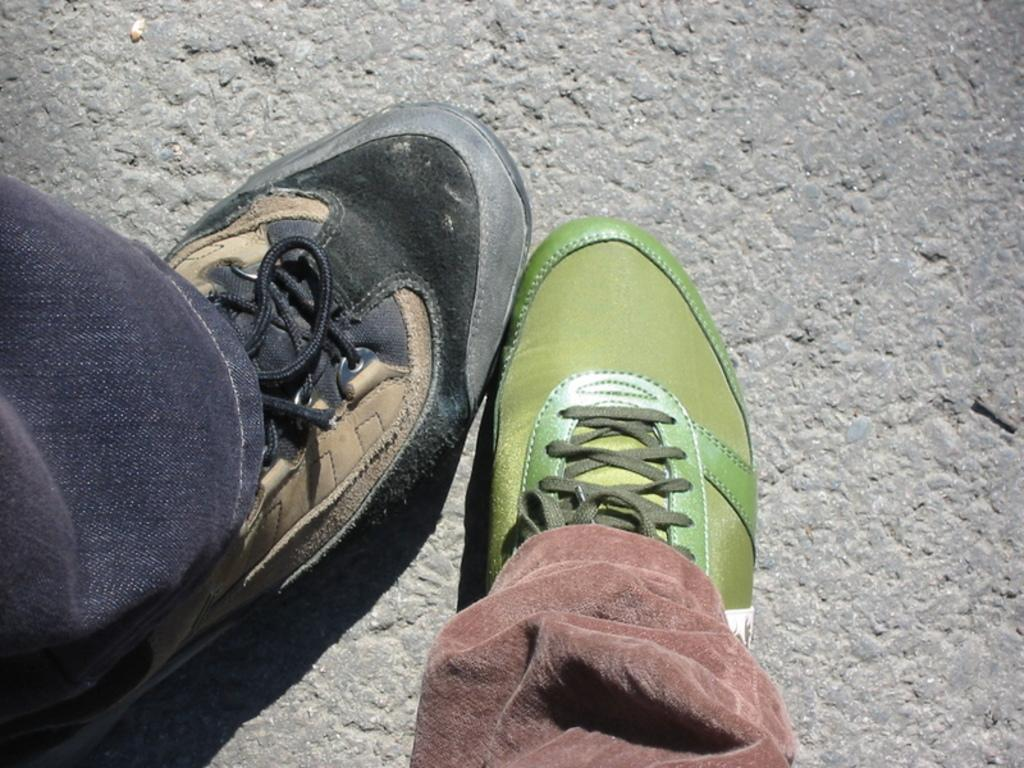What can be seen in the image related to the legs of two different persons? There are two legs of two different persons in the image. Can you describe the clothing and footwear on the right leg? On the right leg, there is a green shoe and a brown pant. How about the left leg? What can be seen there? On the left leg, there is a blue pant and a black and brown shoe. What is the topic of the discussion happening between the snakes in the image? There are no snakes present in the image, so it is not possible to determine the topic of any discussion. 